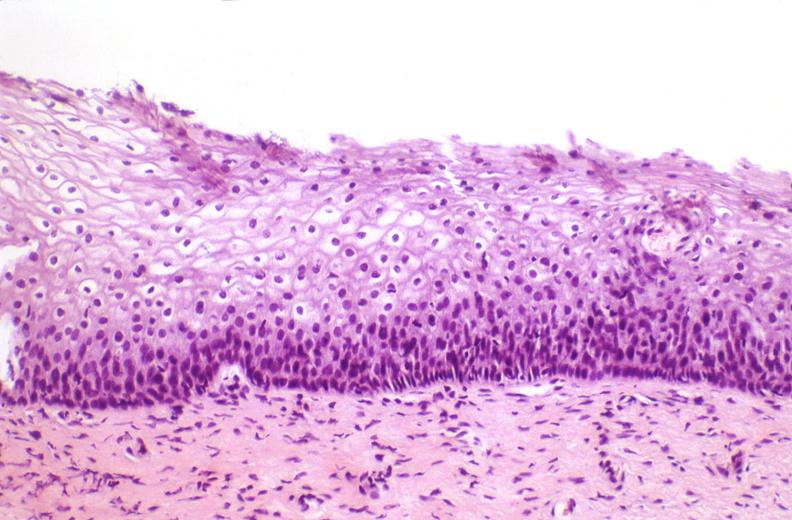s female reproductive present?
Answer the question using a single word or phrase. Yes 